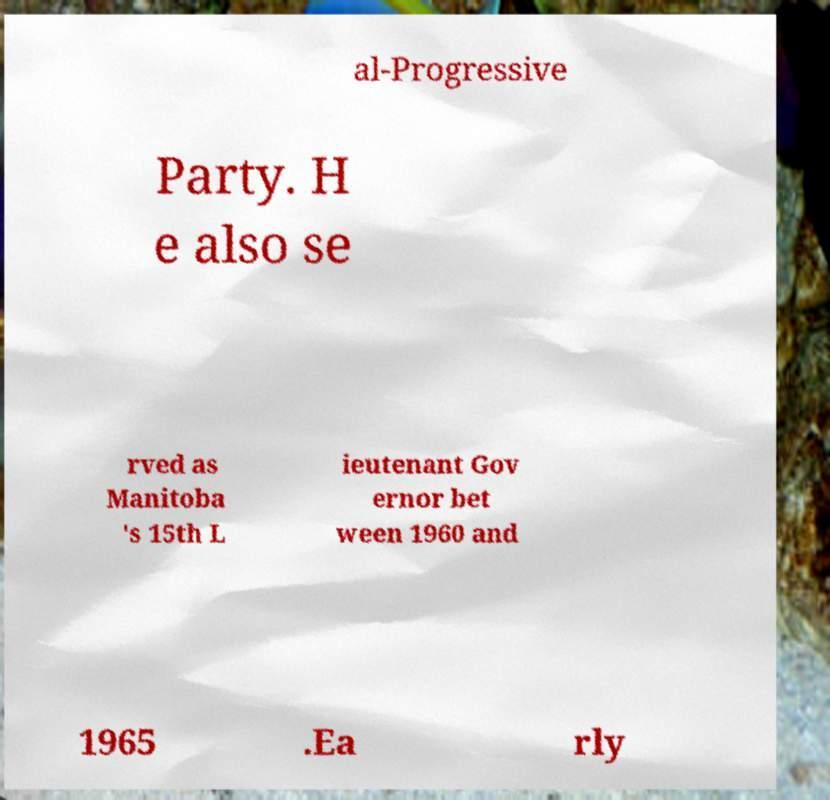Could you assist in decoding the text presented in this image and type it out clearly? al-Progressive Party. H e also se rved as Manitoba 's 15th L ieutenant Gov ernor bet ween 1960 and 1965 .Ea rly 